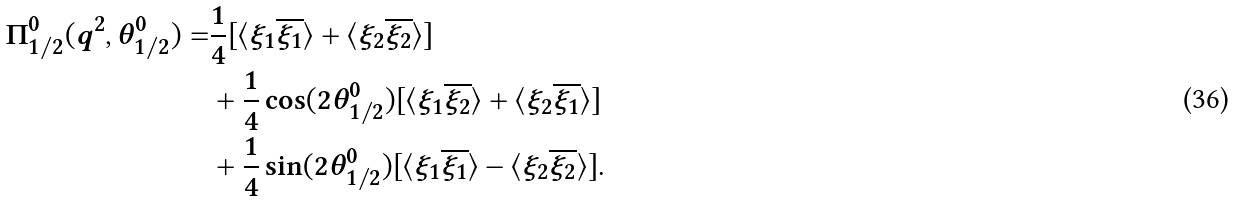<formula> <loc_0><loc_0><loc_500><loc_500>\Pi ^ { 0 } _ { 1 / 2 } ( q ^ { 2 } , \theta ^ { 0 } _ { 1 / 2 } ) = & \frac { 1 } { 4 } [ \langle \xi _ { 1 } \overline { \xi _ { 1 } } \rangle + \langle \xi _ { 2 } \overline { \xi _ { 2 } } \rangle ] \\ & + \frac { 1 } { 4 } \cos ( 2 \theta ^ { 0 } _ { 1 / 2 } ) [ \langle \xi _ { 1 } \overline { \xi _ { 2 } } \rangle + \langle \xi _ { 2 } \overline { \xi _ { 1 } } \rangle ] \\ & + \frac { 1 } { 4 } \sin ( 2 \theta ^ { 0 } _ { 1 / 2 } ) [ \langle \xi _ { 1 } \overline { \xi _ { 1 } } \rangle - \langle \xi _ { 2 } \overline { \xi _ { 2 } } \rangle ] .</formula> 